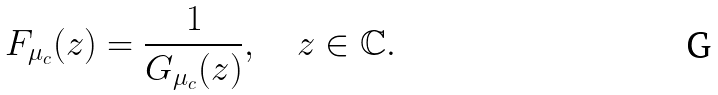<formula> <loc_0><loc_0><loc_500><loc_500>F _ { \mu _ { c } } ( z ) = \frac { 1 } { G _ { \mu _ { c } } ( z ) } , \quad z \in \mathbb { C } .</formula> 